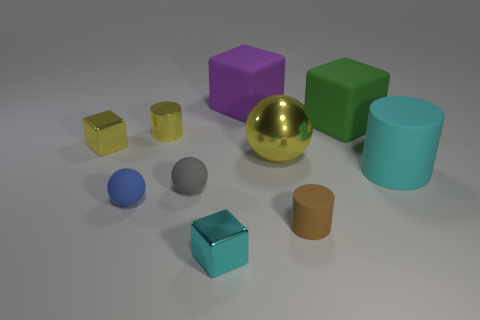Are there any large matte cylinders that are to the left of the large matte block that is on the right side of the big yellow shiny object?
Offer a very short reply. No. How many tiny brown rubber cylinders are to the left of the big green thing?
Your response must be concise. 1. How many other things are the same color as the metal ball?
Offer a very short reply. 2. Is the number of small things behind the big cylinder less than the number of rubber things in front of the yellow cube?
Your response must be concise. Yes. What number of things are small matte objects that are right of the cyan shiny thing or yellow spheres?
Give a very brief answer. 2. There is a cyan rubber cylinder; is its size the same as the rubber cylinder left of the large rubber cylinder?
Make the answer very short. No. There is another rubber object that is the same shape as the brown matte thing; what size is it?
Your answer should be very brief. Large. There is a yellow metallic thing right of the gray thing that is on the left side of the green thing; how many gray objects are behind it?
Offer a very short reply. 0. What number of cylinders are small purple matte things or cyan metal things?
Your response must be concise. 0. There is a tiny shiny block that is on the right side of the tiny cylinder left of the tiny metallic thing in front of the small brown matte object; what is its color?
Your response must be concise. Cyan. 